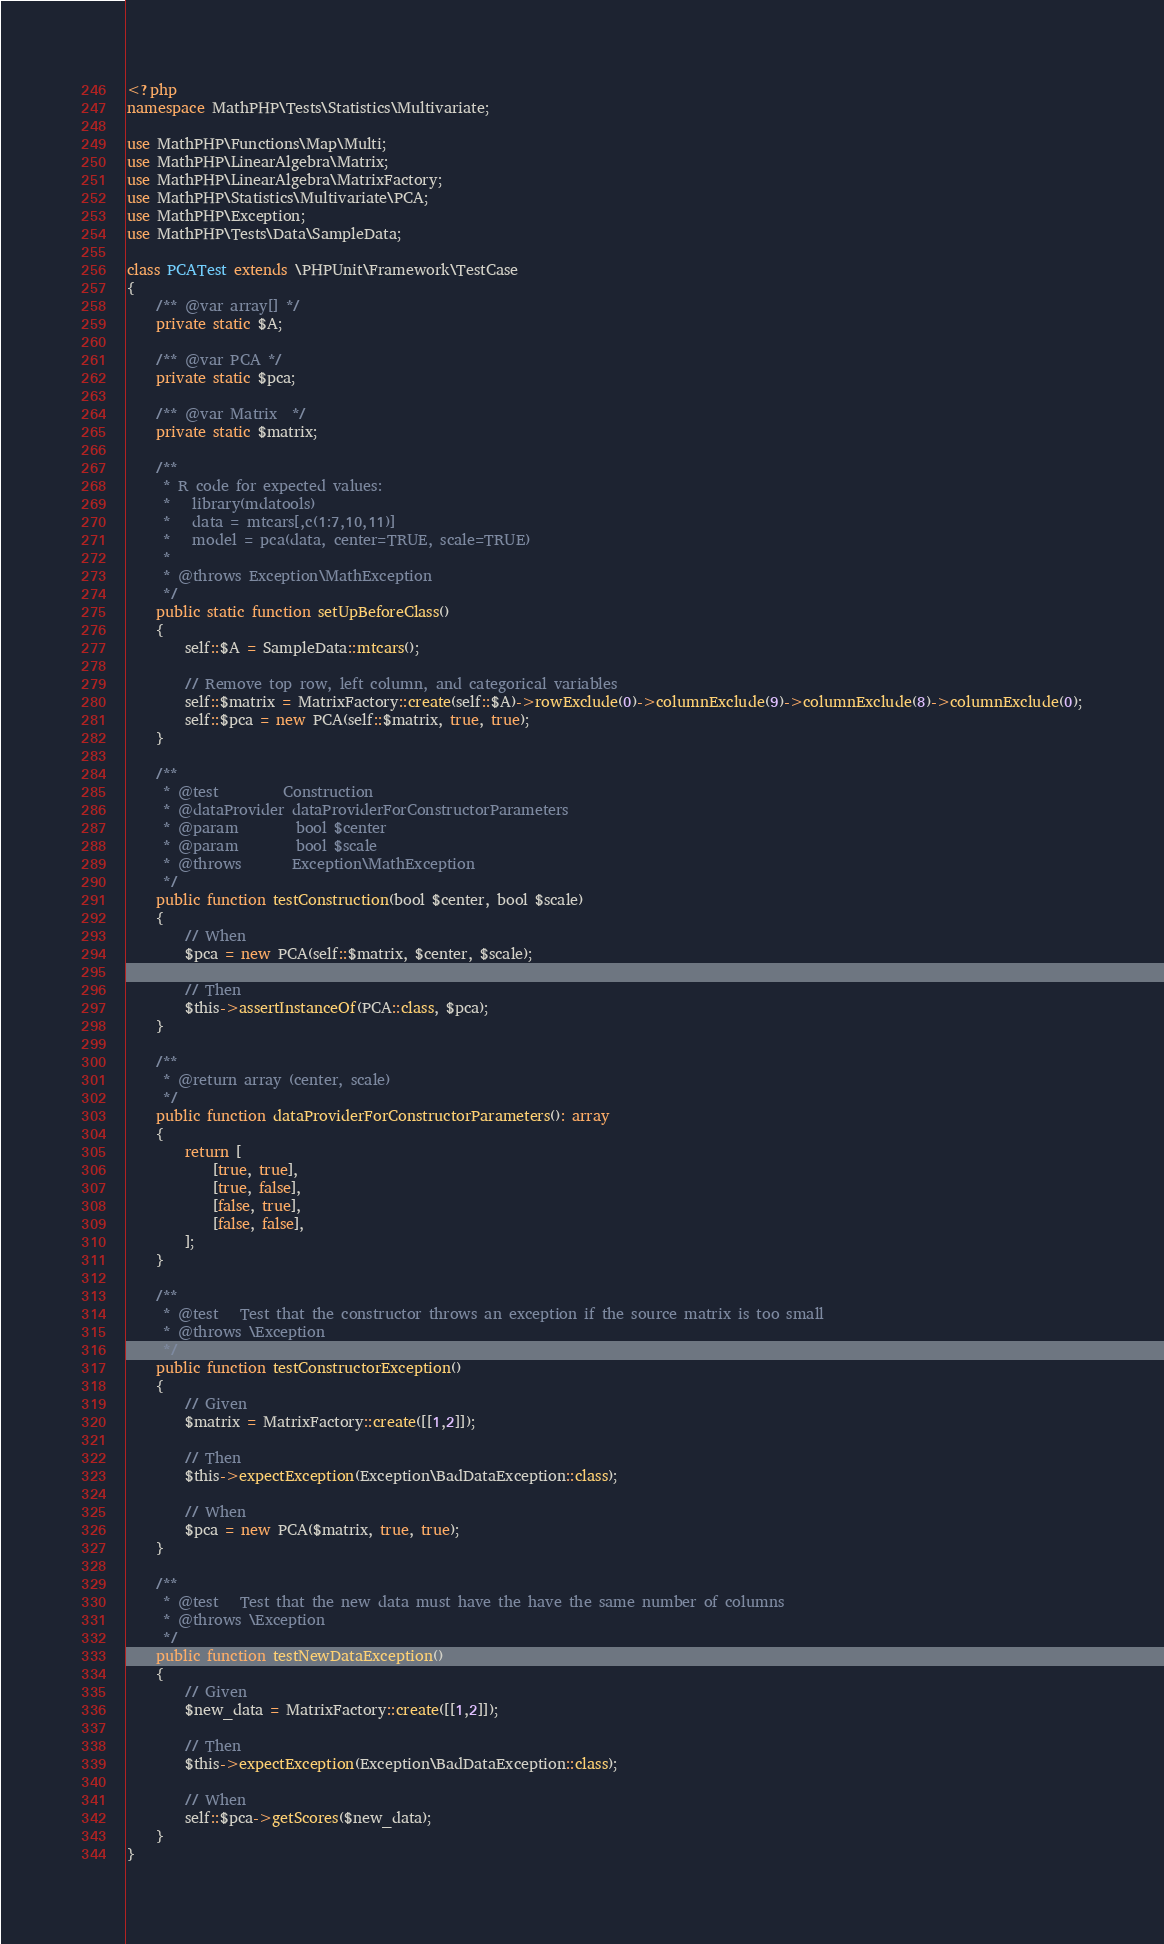Convert code to text. <code><loc_0><loc_0><loc_500><loc_500><_PHP_><?php
namespace MathPHP\Tests\Statistics\Multivariate;

use MathPHP\Functions\Map\Multi;
use MathPHP\LinearAlgebra\Matrix;
use MathPHP\LinearAlgebra\MatrixFactory;
use MathPHP\Statistics\Multivariate\PCA;
use MathPHP\Exception;
use MathPHP\Tests\Data\SampleData;

class PCATest extends \PHPUnit\Framework\TestCase
{
    /** @var array[] */
    private static $A;

    /** @var PCA */
    private static $pca;

    /** @var Matrix  */
    private static $matrix;

    /**
     * R code for expected values:
     *   library(mdatools)
     *   data = mtcars[,c(1:7,10,11)]
     *   model = pca(data, center=TRUE, scale=TRUE)
     *
     * @throws Exception\MathException
     */
    public static function setUpBeforeClass()
    {
        self::$A = SampleData::mtcars();

        // Remove top row, left column, and categorical variables
        self::$matrix = MatrixFactory::create(self::$A)->rowExclude(0)->columnExclude(9)->columnExclude(8)->columnExclude(0);
        self::$pca = new PCA(self::$matrix, true, true);
    }

    /**
     * @test         Construction
     * @dataProvider dataProviderForConstructorParameters
     * @param        bool $center
     * @param        bool $scale
     * @throws       Exception\MathException
     */
    public function testConstruction(bool $center, bool $scale)
    {
        // When
        $pca = new PCA(self::$matrix, $center, $scale);

        // Then
        $this->assertInstanceOf(PCA::class, $pca);
    }

    /**
     * @return array (center, scale)
     */
    public function dataProviderForConstructorParameters(): array
    {
        return [
            [true, true],
            [true, false],
            [false, true],
            [false, false],
        ];
    }

    /**
     * @test   Test that the constructor throws an exception if the source matrix is too small
     * @throws \Exception
     */
    public function testConstructorException()
    {
        // Given
        $matrix = MatrixFactory::create([[1,2]]);

        // Then
        $this->expectException(Exception\BadDataException::class);

        // When
        $pca = new PCA($matrix, true, true);
    }

    /**
     * @test   Test that the new data must have the have the same number of columns
     * @throws \Exception
     */
    public function testNewDataException()
    {
        // Given
        $new_data = MatrixFactory::create([[1,2]]);

        // Then
        $this->expectException(Exception\BadDataException::class);

        // When
        self::$pca->getScores($new_data);
    }
}
</code> 